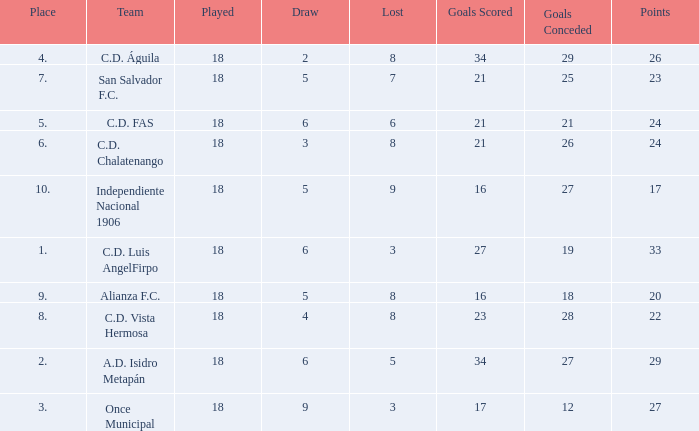What were the goal conceded that had a lost greater than 8 and more than 17 points? None. 